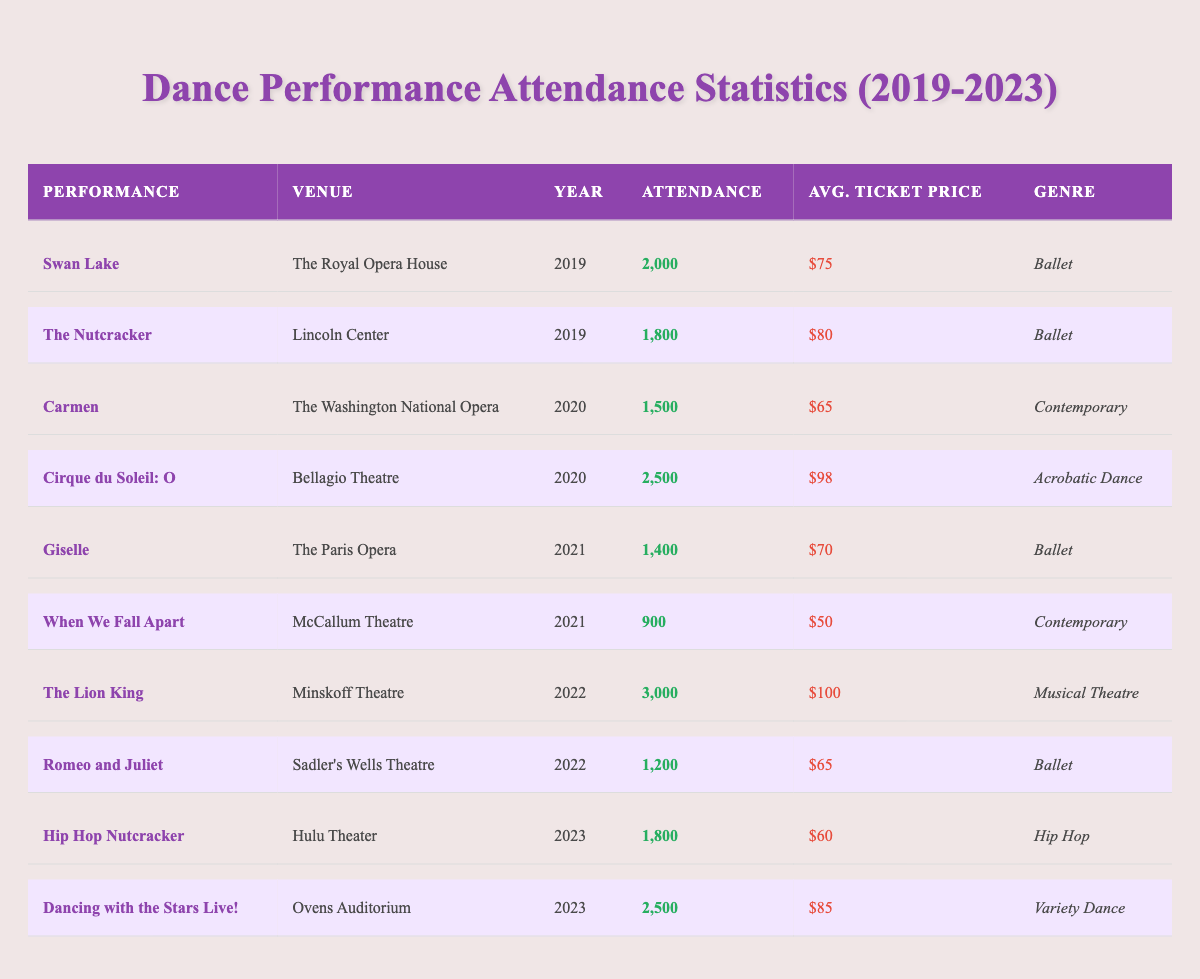What was the attendance for "The Lion King"? The table shows the entry for "The Lion King", where the attendance is listed directly as 3,000.
Answer: 3,000 Which dance performance had the highest average ticket price? By comparing the 'Avg. Ticket Price' for each performance, "The Lion King" has the highest price at $100.
Answer: $100 How many performances had an attendance of over 2,000? Looking through the attendance column, "Swan Lake" (2,000), "Cirque du Soleil: O" (2,500), "The Lion King" (3,000), and "Dancing with the Stars Live!" (2,500) meet the criteria of over 2,000, totaling four performances.
Answer: 4 Is "Giselle" a contemporary performance? Checking the genre for "Giselle", it is classified as "Ballet", which means it is not contemporary.
Answer: No What is the total attendance for all performances in 2020? The performances in 2020 are "Carmen" (1,500) and "Cirque du Soleil: O" (2,500). Summing them gives: 1,500 + 2,500 = 4,000 for the total attendance in that year.
Answer: 4,000 What was the average attendance over the years 2019 to 2023? First, we add the attendance for each year: 2,000 (2019) + 1,800 (2019) + 1,500 (2020) + 2,500 (2020) + 1,400 (2021) + 900 (2021) + 3,000 (2022) + 1,200 (2022) + 1,800 (2023) + 2,500 (2023) = 17,800. There are 10 performances, so the average is 17,800 / 10 = 1,780.
Answer: 1,780 Which genre had the least attendance in a single performance? Looking through the attendance data, "When We Fall Apart" (900) is the lowest figure recorded, and it is classified as "Contemporary".
Answer: Contemporary (900) Did "The Nutcracker" have a higher attendance than "Romeo and Juliet"? Comparing attendance figures: "The Nutcracker" = 1,800 and "Romeo and Juliet" = 1,200. Since 1,800 is greater than 1,200, it confirms the statement.
Answer: Yes What is the difference in average ticket prices between ballet and contemporary performances? The average ticket prices for ballet performances are $75 (Swan Lake) + $80 (The Nutcracker) + $70 (Giselle) + $65 (Romeo and Juliet) = $290, divided by 4 = $72.5. For contemporary, there is $65 (Carmen) + $50 (When We Fall Apart) = $115 for 2 performances, giving an average of $57.5. The difference is $72.5 - $57.5 = $15.
Answer: $15 Which performance had the greatest attendance in 2022? The table lists "The Lion King" with an attendance of 3,000 compared to "Romeo and Juliet" at 1,200, making it the highest in 2022.
Answer: "The Lion King" How does the average attendance of contemporary performances compare with the overall average attendance? For contemporary, attendance figures are "Carmen" (1,500) and "When We Fall Apart" (900), averaging to (1,500 + 900) / 2 = 1,200. The overall average attendance from previous calculation is 1,780. Since 1,200 is less than 1,780, contemporary performances have lower average attendance.
Answer: Lower than overall average 